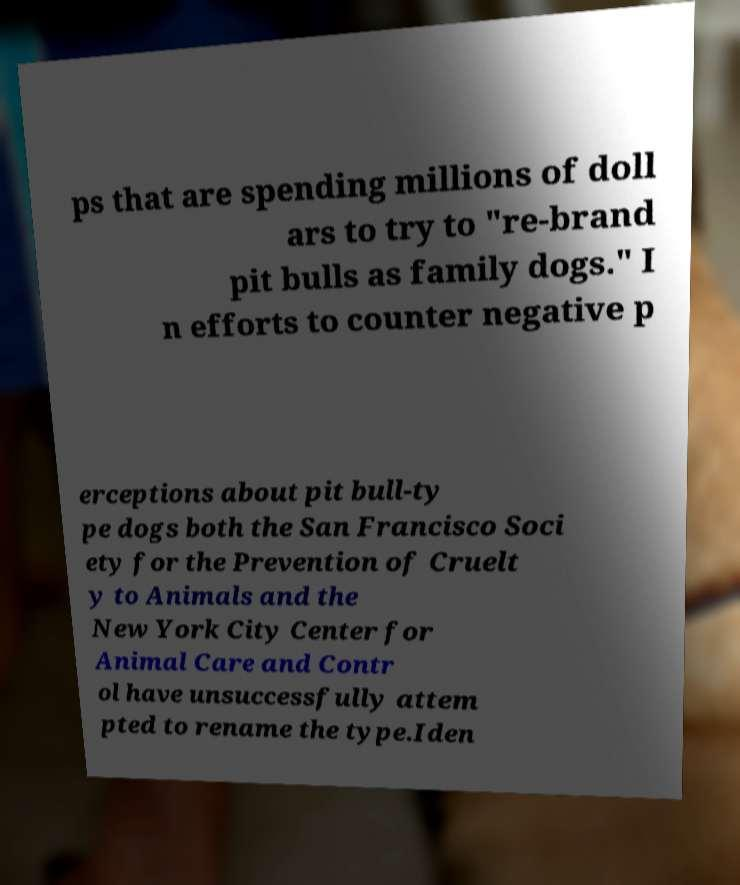Could you extract and type out the text from this image? ps that are spending millions of doll ars to try to "re-brand pit bulls as family dogs." I n efforts to counter negative p erceptions about pit bull-ty pe dogs both the San Francisco Soci ety for the Prevention of Cruelt y to Animals and the New York City Center for Animal Care and Contr ol have unsuccessfully attem pted to rename the type.Iden 